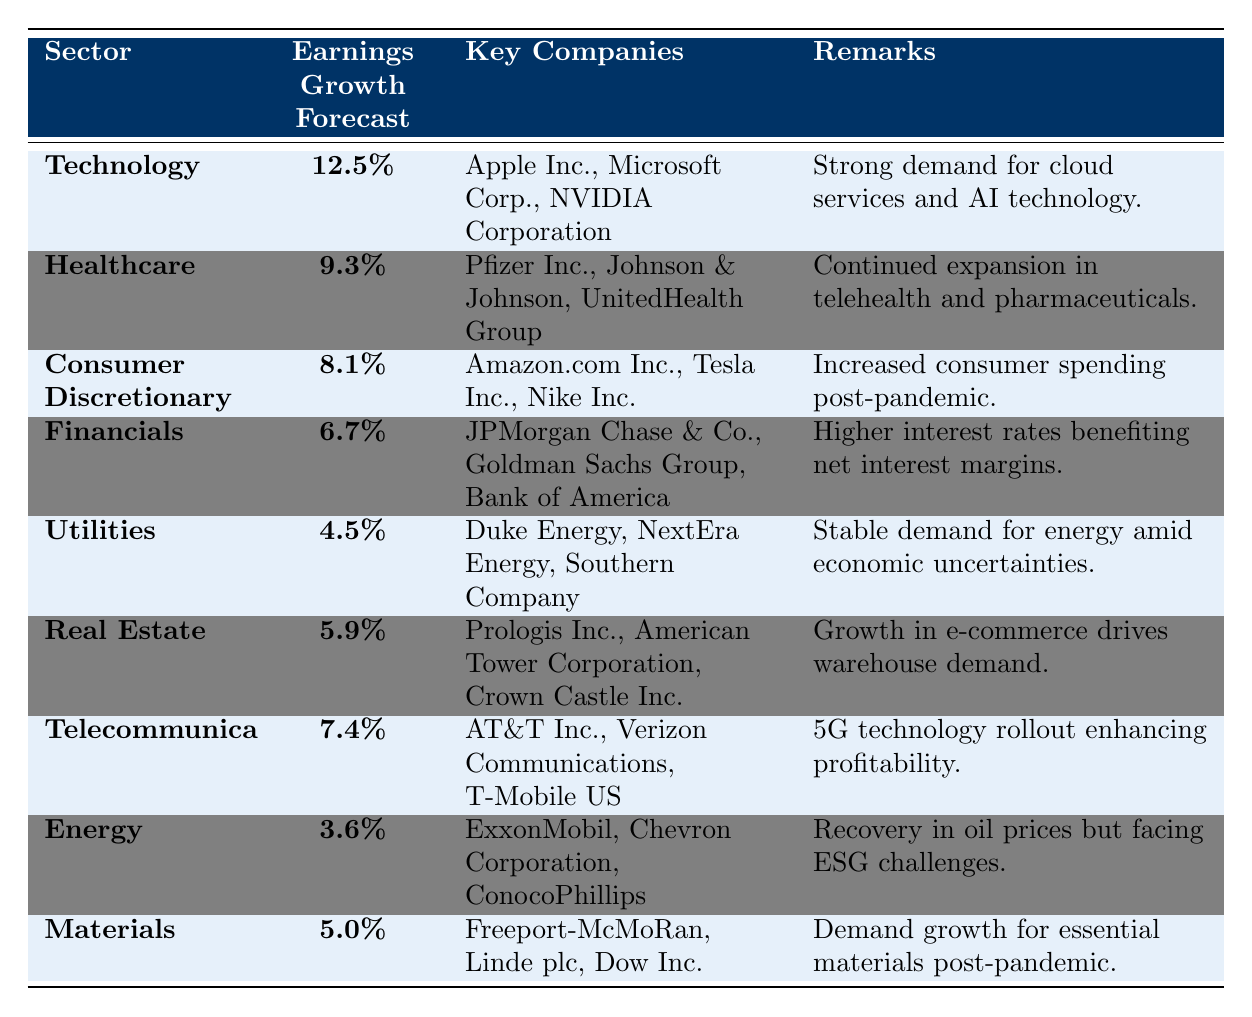What is the earnings growth forecast for the Technology sector? The table lists the earnings growth forecast for the Technology sector as 12.5% in the corresponding row.
Answer: 12.5% Which sector has the lowest earnings growth forecast? By reviewing the earnings growth forecasts in the table, the Energy sector has the lowest at 3.6%.
Answer: Energy sector Which three companies are listed under the Telecommunications sector? The Key Companies listed in the Telecommunications sector are AT&T Inc., Verizon Communications, and T-Mobile US.
Answer: AT&T Inc., Verizon Communications, T-Mobile US Is the earnings growth forecast for Consumer Discretionary greater than that for Utilities? The earnings growth forecast for Consumer Discretionary is 8.1%, while Utilities is 4.5%. Since 8.1% is greater than 4.5%, the answer is yes.
Answer: Yes What is the difference in earnings growth forecast between the Healthcare and Financials sectors? The Healthcare sector has a forecast of 9.3% and the Financials sector has 6.7%. The difference is 9.3% - 6.7% = 2.6%.
Answer: 2.6% Which sector has an earnings growth forecast that is closest to the average of all sectors? Calculate the average of all the earnings growth forecasts. (12.5 + 9.3 + 8.1 + 6.7 + 4.5 + 5.9 + 7.4 + 3.6 + 5.0) / 9 = 6.67%. The sector closest to this average is Financials with 6.7%.
Answer: Financials What is the total earnings growth forecast for the sectors listed in Renewable Energy (Utilities and Energy)? The Utilities sector has an earnings growth of 4.5% and the Energy sector has 3.6%. Thus, the total is 4.5% + 3.6% = 8.1%.
Answer: 8.1% Do more sectors have written remarks indicating growth opportunities or challenges? Counting the remarks, there are 5 that indicate growth opportunities (Technology, Healthcare, Consumer Discretionary, Real Estate, Telecommunications) and 4 that mention challenges or risks (Financials, Utilities, Energy, and Materials). Thus, more sectors indicate growth.
Answer: Yes What is the cumulative earnings growth forecast of the top two sectors? The top two sectors are Technology (12.5%) and Healthcare (9.3%). Their cumulative forecast is 12.5% + 9.3% = 21.8%.
Answer: 21.8% Which sector's remarks highlight technology as a growth factor? The Technology sector remarks mention strong demand for cloud services and AI technology, which highlights technology as a growth factor.
Answer: Technology sector 